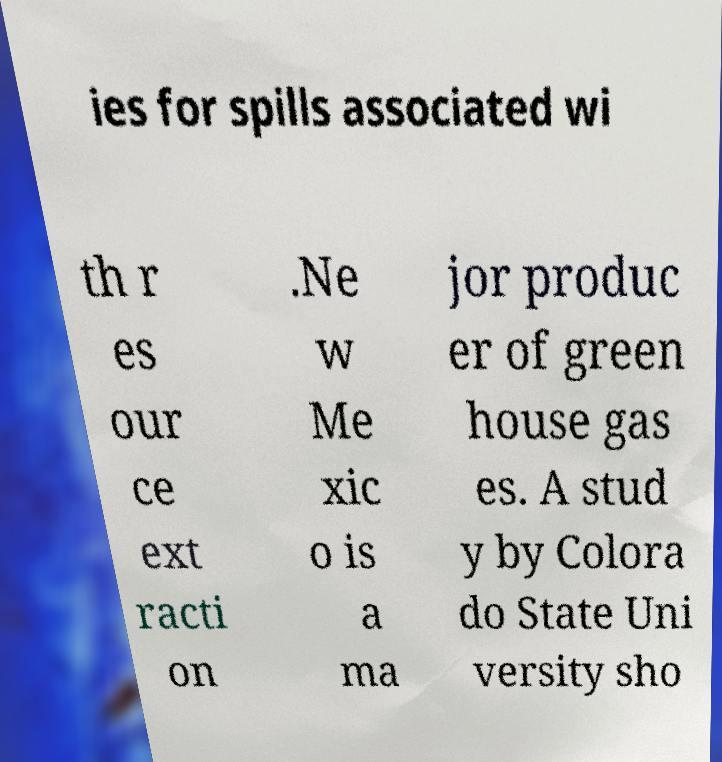Could you assist in decoding the text presented in this image and type it out clearly? ies for spills associated wi th r es our ce ext racti on .Ne w Me xic o is a ma jor produc er of green house gas es. A stud y by Colora do State Uni versity sho 